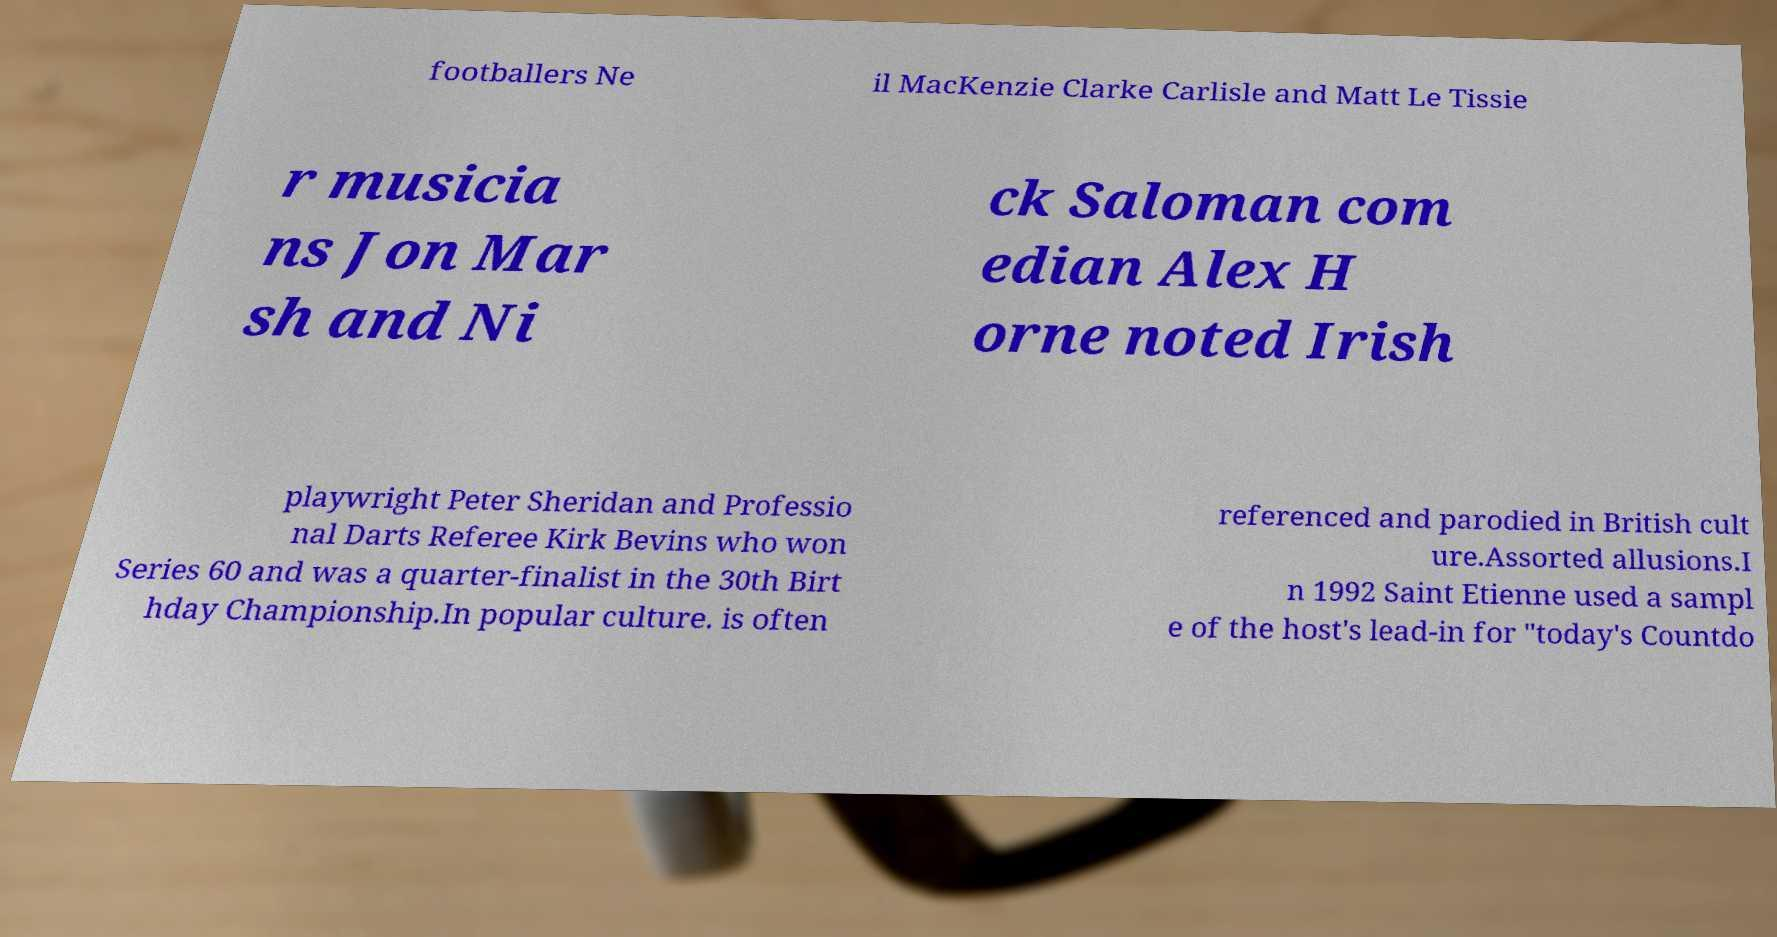There's text embedded in this image that I need extracted. Can you transcribe it verbatim? footballers Ne il MacKenzie Clarke Carlisle and Matt Le Tissie r musicia ns Jon Mar sh and Ni ck Saloman com edian Alex H orne noted Irish playwright Peter Sheridan and Professio nal Darts Referee Kirk Bevins who won Series 60 and was a quarter-finalist in the 30th Birt hday Championship.In popular culture. is often referenced and parodied in British cult ure.Assorted allusions.I n 1992 Saint Etienne used a sampl e of the host's lead-in for "today's Countdo 